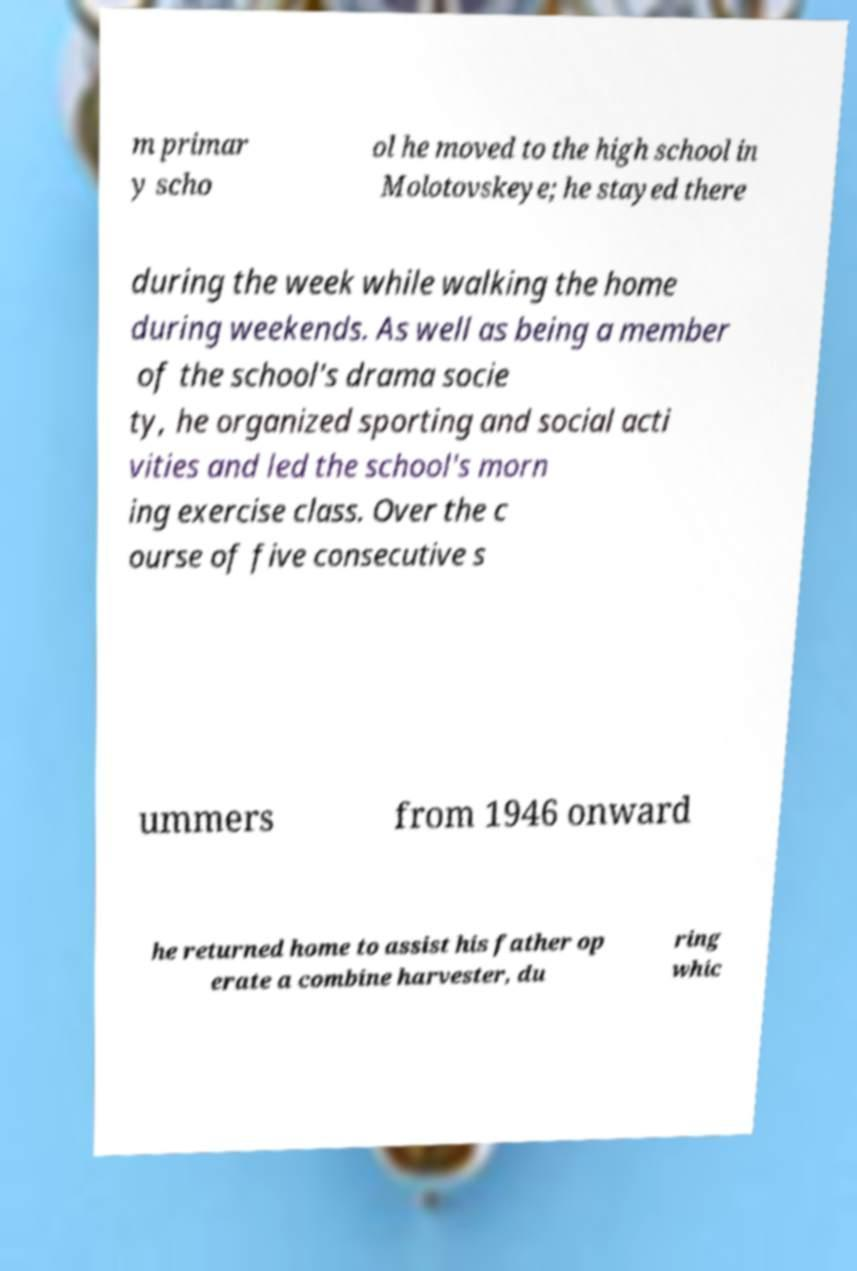Please read and relay the text visible in this image. What does it say? m primar y scho ol he moved to the high school in Molotovskeye; he stayed there during the week while walking the home during weekends. As well as being a member of the school's drama socie ty, he organized sporting and social acti vities and led the school's morn ing exercise class. Over the c ourse of five consecutive s ummers from 1946 onward he returned home to assist his father op erate a combine harvester, du ring whic 